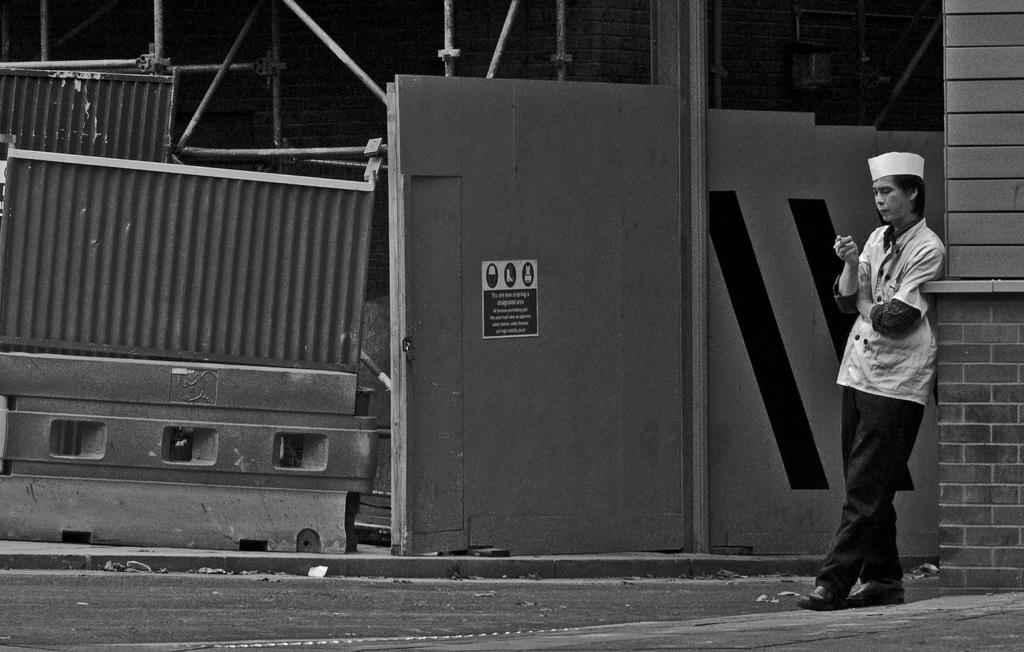What is the main subject of the image? The main subject of the image is a person standing on the right side. Where is the person standing in the image? The person is standing at a wall. What can be seen on the ground in the image? There is a divider on the ground in the image. How much payment is the person receiving in the image? There is no indication of payment in the image; it only shows a person standing at a wall with a divider on the ground. Can you tell me the color of the kitty in the image? There is no kitty present in the image. 